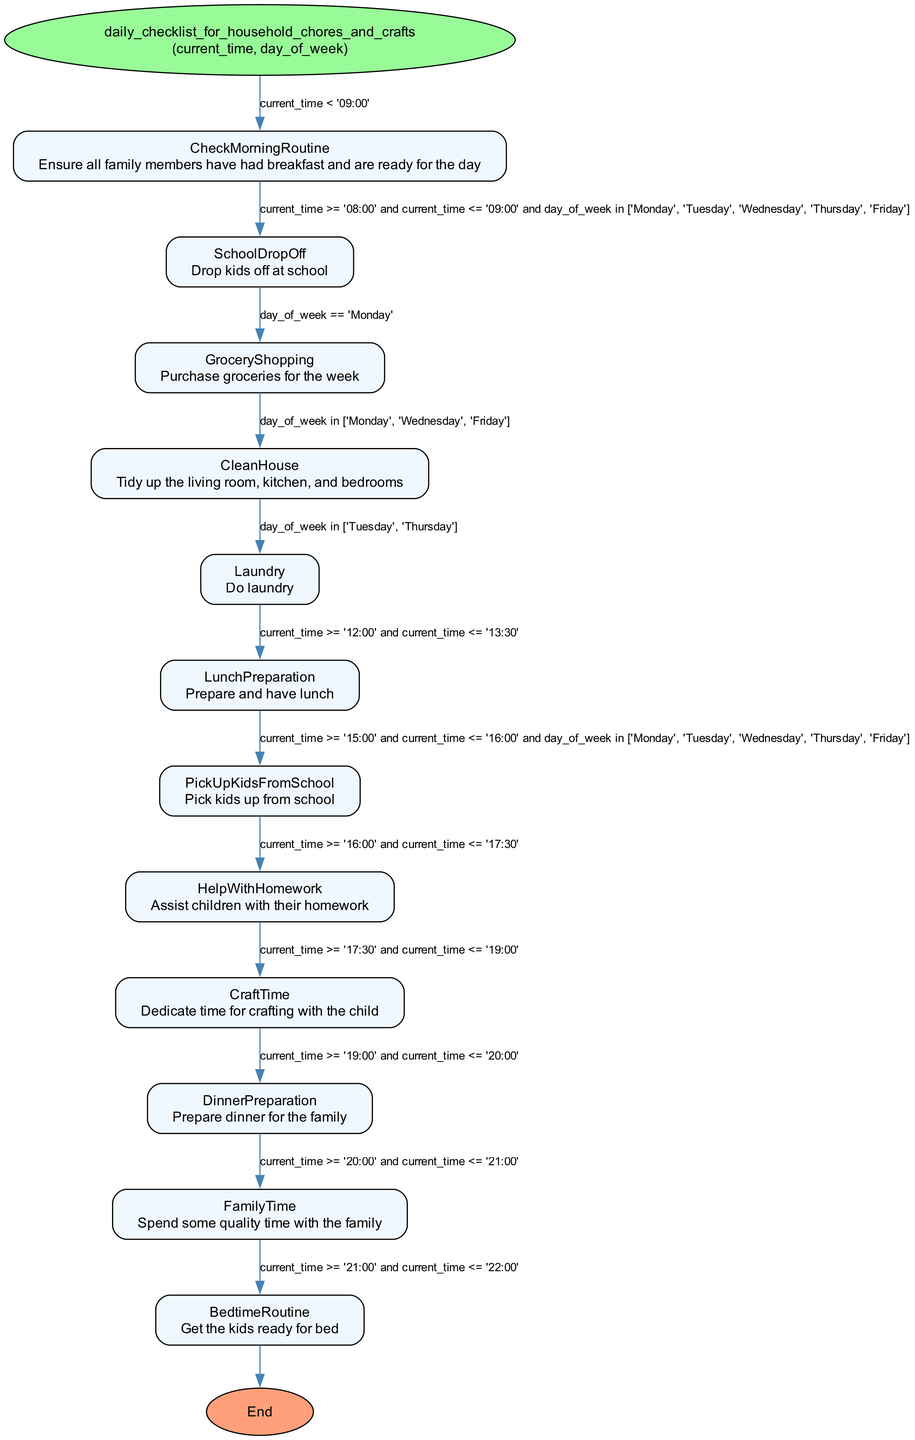What is the first action on the checklist? The first action on the checklist is labeled as "CheckMorningRoutine," which ensures all family members have had breakfast and are ready for the day. This action is represented as the first node in the flowchart.
Answer: CheckMorningRoutine How many total actions are in the checklist? The diagram lists a total of 12 actions or elements, which are distinct nodes that represent different chores and activities throughout the day.
Answer: 12 What is the conditional for doing laundry? The condition for doing laundry is that it must be either Tuesday or Thursday, as indicated in the "Laundry" node. This is a specific criterion mentioned in the conditional of that node.
Answer: Tuesday or Thursday Which action comes after "LunchPreparation"? The action that follows "LunchPreparation" is "PickUpKidsFromSchool," indicating that after lunch, the next chore is to pick the kids up from school, as per the flow of the diagram.
Answer: PickUpKidsFromSchool Which two days involve cleaning the house? The days indicated for cleaning the house are Monday, Wednesday, and Friday. Therefore, any two days can be chosen from this group.
Answer: Monday and Wednesday What is the last action before bedtime routine? The last action before the "BedtimeRoutine" is "FamilyTime," which takes place between 8 PM and 9 PM, as per the order of actions in the flowchart.
Answer: FamilyTime What is the time range for "CraftTime"? The time range for "CraftTime" is specified as after 5:30 PM and before 7:00 PM, indicating when the family should dedicate time for crafting activities.
Answer: 5:30 PM to 7:00 PM Which action requires grocery shopping? The action that requires grocery shopping is "GroceryShopping," which occurs only on Monday, making this condition unique to that day of the week.
Answer: GroceryShopping What do you do before dinner preparation? Before "DinnerPreparation," the identified action is "CraftTime," which should be completed prior to preparing dinner. This indicates a sequence in the flow of daily activities.
Answer: CraftTime 